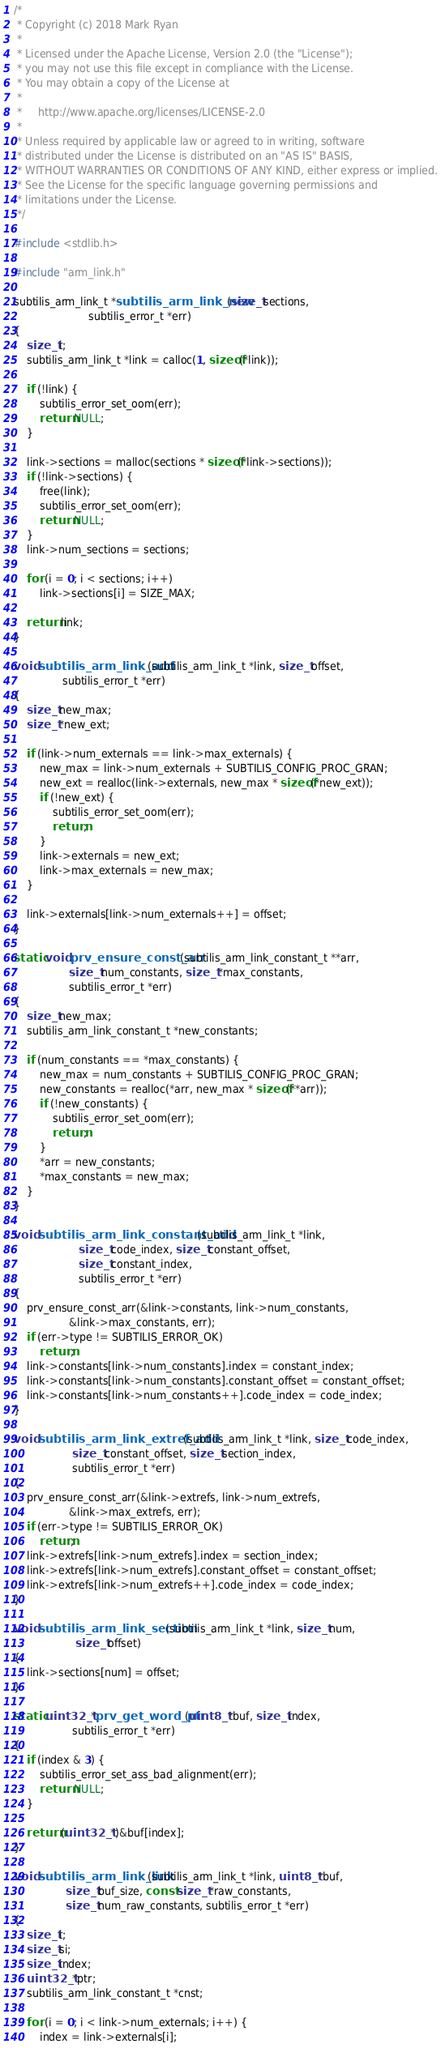<code> <loc_0><loc_0><loc_500><loc_500><_C_>/*
 * Copyright (c) 2018 Mark Ryan
 *
 * Licensed under the Apache License, Version 2.0 (the "License");
 * you may not use this file except in compliance with the License.
 * You may obtain a copy of the License at
 *
 *     http://www.apache.org/licenses/LICENSE-2.0
 *
 * Unless required by applicable law or agreed to in writing, software
 * distributed under the License is distributed on an "AS IS" BASIS,
 * WITHOUT WARRANTIES OR CONDITIONS OF ANY KIND, either express or implied.
 * See the License for the specific language governing permissions and
 * limitations under the License.
 */

#include <stdlib.h>

#include "arm_link.h"

subtilis_arm_link_t *subtilis_arm_link_new(size_t sections,
					   subtilis_error_t *err)
{
	size_t i;
	subtilis_arm_link_t *link = calloc(1, sizeof(*link));

	if (!link) {
		subtilis_error_set_oom(err);
		return NULL;
	}

	link->sections = malloc(sections * sizeof(*link->sections));
	if (!link->sections) {
		free(link);
		subtilis_error_set_oom(err);
		return NULL;
	}
	link->num_sections = sections;

	for (i = 0; i < sections; i++)
		link->sections[i] = SIZE_MAX;

	return link;
}

void subtilis_arm_link_add(subtilis_arm_link_t *link, size_t offset,
			   subtilis_error_t *err)
{
	size_t new_max;
	size_t *new_ext;

	if (link->num_externals == link->max_externals) {
		new_max = link->num_externals + SUBTILIS_CONFIG_PROC_GRAN;
		new_ext = realloc(link->externals, new_max * sizeof(*new_ext));
		if (!new_ext) {
			subtilis_error_set_oom(err);
			return;
		}
		link->externals = new_ext;
		link->max_externals = new_max;
	}

	link->externals[link->num_externals++] = offset;
}

static void prv_ensure_const_arr(subtilis_arm_link_constant_t **arr,
				 size_t num_constants, size_t *max_constants,
				 subtilis_error_t *err)
{
	size_t new_max;
	subtilis_arm_link_constant_t *new_constants;

	if (num_constants == *max_constants) {
		new_max = num_constants + SUBTILIS_CONFIG_PROC_GRAN;
		new_constants = realloc(*arr, new_max * sizeof(**arr));
		if (!new_constants) {
			subtilis_error_set_oom(err);
			return;
		}
		*arr = new_constants;
		*max_constants = new_max;
	}
}

void subtilis_arm_link_constant_add(subtilis_arm_link_t *link,
				    size_t code_index, size_t constant_offset,
				    size_t constant_index,
				    subtilis_error_t *err)
{
	prv_ensure_const_arr(&link->constants, link->num_constants,
			     &link->max_constants, err);
	if (err->type != SUBTILIS_ERROR_OK)
		return;
	link->constants[link->num_constants].index = constant_index;
	link->constants[link->num_constants].constant_offset = constant_offset;
	link->constants[link->num_constants++].code_index = code_index;
}

void subtilis_arm_link_extref_add(subtilis_arm_link_t *link, size_t code_index,
				  size_t constant_offset, size_t section_index,
				  subtilis_error_t *err)
{
	prv_ensure_const_arr(&link->extrefs, link->num_extrefs,
			     &link->max_extrefs, err);
	if (err->type != SUBTILIS_ERROR_OK)
		return;
	link->extrefs[link->num_extrefs].index = section_index;
	link->extrefs[link->num_extrefs].constant_offset = constant_offset;
	link->extrefs[link->num_extrefs++].code_index = code_index;
}

void subtilis_arm_link_section(subtilis_arm_link_t *link, size_t num,
			       size_t offset)
{
	link->sections[num] = offset;
}

static uint32_t *prv_get_word_ptr(uint8_t *buf, size_t index,
				  subtilis_error_t *err)
{
	if (index & 3) {
		subtilis_error_set_ass_bad_alignment(err);
		return NULL;
	}

	return (uint32_t *)&buf[index];
}

void subtilis_arm_link_link(subtilis_arm_link_t *link, uint8_t *buf,
			    size_t buf_size, const size_t *raw_constants,
			    size_t num_raw_constants, subtilis_error_t *err)
{
	size_t i;
	size_t si;
	size_t index;
	uint32_t *ptr;
	subtilis_arm_link_constant_t *cnst;

	for (i = 0; i < link->num_externals; i++) {
		index = link->externals[i];</code> 